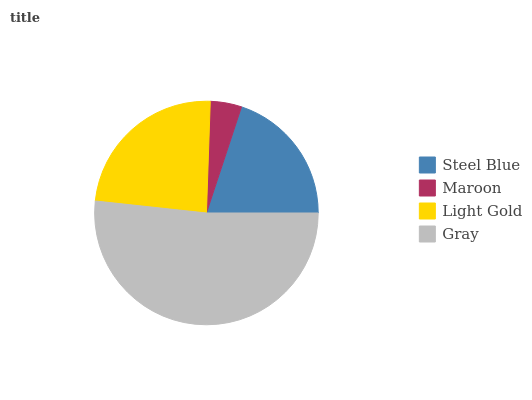Is Maroon the minimum?
Answer yes or no. Yes. Is Gray the maximum?
Answer yes or no. Yes. Is Light Gold the minimum?
Answer yes or no. No. Is Light Gold the maximum?
Answer yes or no. No. Is Light Gold greater than Maroon?
Answer yes or no. Yes. Is Maroon less than Light Gold?
Answer yes or no. Yes. Is Maroon greater than Light Gold?
Answer yes or no. No. Is Light Gold less than Maroon?
Answer yes or no. No. Is Light Gold the high median?
Answer yes or no. Yes. Is Steel Blue the low median?
Answer yes or no. Yes. Is Gray the high median?
Answer yes or no. No. Is Light Gold the low median?
Answer yes or no. No. 